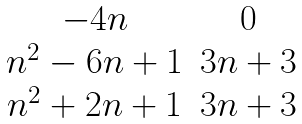<formula> <loc_0><loc_0><loc_500><loc_500>\begin{matrix} - 4 n & 0 \\ n ^ { 2 } - 6 n + 1 & 3 n + 3 \\ n ^ { 2 } + 2 n + 1 & 3 n + 3 \end{matrix}</formula> 